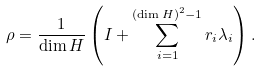<formula> <loc_0><loc_0><loc_500><loc_500>\rho = \frac { 1 } { \dim H } \left ( I + \sum _ { i = 1 } ^ { ( \dim H ) ^ { 2 } - 1 } r _ { i } \lambda _ { i } \right ) .</formula> 